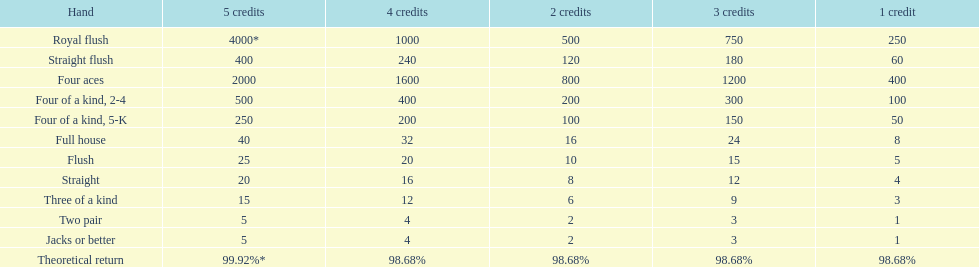What is the payout for achieving a full house and winning on four credits? 32. 